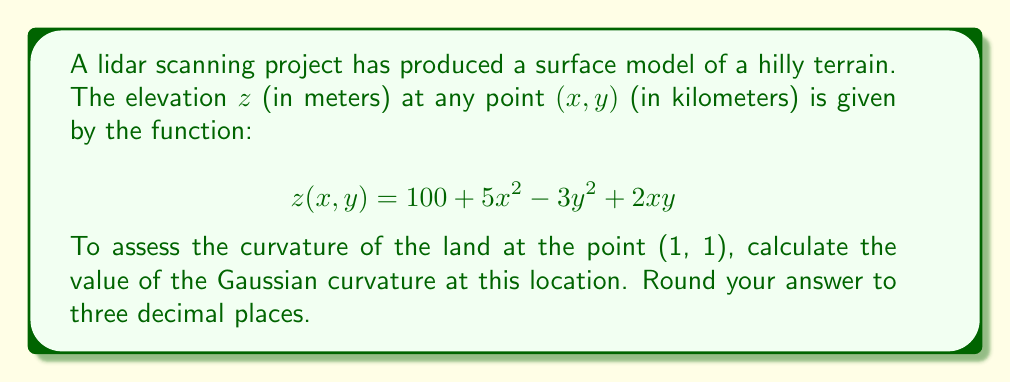Provide a solution to this math problem. To find the Gaussian curvature, we need to calculate the second partial derivatives and use the formula for Gaussian curvature.

Step 1: Calculate the required partial derivatives:
$\frac{\partial z}{\partial x} = 10x + 2y$
$\frac{\partial z}{\partial y} = -6y + 2x$
$\frac{\partial^2 z}{\partial x^2} = 10$
$\frac{\partial^2 z}{\partial y^2} = -6$
$\frac{\partial^2 z}{\partial x\partial y} = 2$

Step 2: Calculate the values of these derivatives at the point (1, 1):
$\frac{\partial z}{\partial x}(1,1) = 10(1) + 2(1) = 12$
$\frac{\partial z}{\partial y}(1,1) = -6(1) + 2(1) = -4$
$\frac{\partial^2 z}{\partial x^2}(1,1) = 10$
$\frac{\partial^2 z}{\partial y^2}(1,1) = -6$
$\frac{\partial^2 z}{\partial x\partial y}(1,1) = 2$

Step 3: Use the formula for Gaussian curvature:
$$K = \frac{\frac{\partial^2 z}{\partial x^2}\frac{\partial^2 z}{\partial y^2} - (\frac{\partial^2 z}{\partial x\partial y})^2}{(1 + (\frac{\partial z}{\partial x})^2 + (\frac{\partial z}{\partial y})^2)^2}$$

Step 4: Substitute the values:
$$K = \frac{(10)(-6) - (2)^2}{(1 + (12)^2 + (-4)^2)^2}$$

Step 5: Calculate:
$$K = \frac{-60 - 4}{(1 + 144 + 16)^2} = \frac{-64}{161^2} \approx -0.002472$$

Step 6: Round to three decimal places:
$K \approx -0.002$
Answer: -0.002 